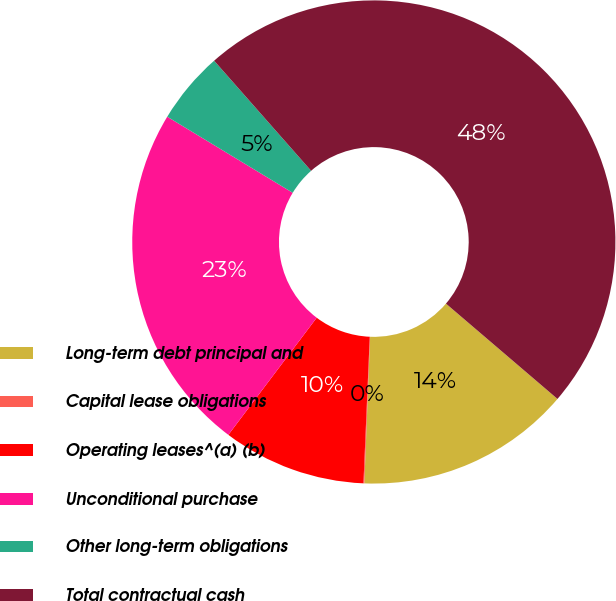Convert chart to OTSL. <chart><loc_0><loc_0><loc_500><loc_500><pie_chart><fcel>Long-term debt principal and<fcel>Capital lease obligations<fcel>Operating leases^(a) (b)<fcel>Unconditional purchase<fcel>Other long-term obligations<fcel>Total contractual cash<nl><fcel>14.37%<fcel>0.06%<fcel>9.6%<fcel>23.39%<fcel>4.83%<fcel>47.75%<nl></chart> 